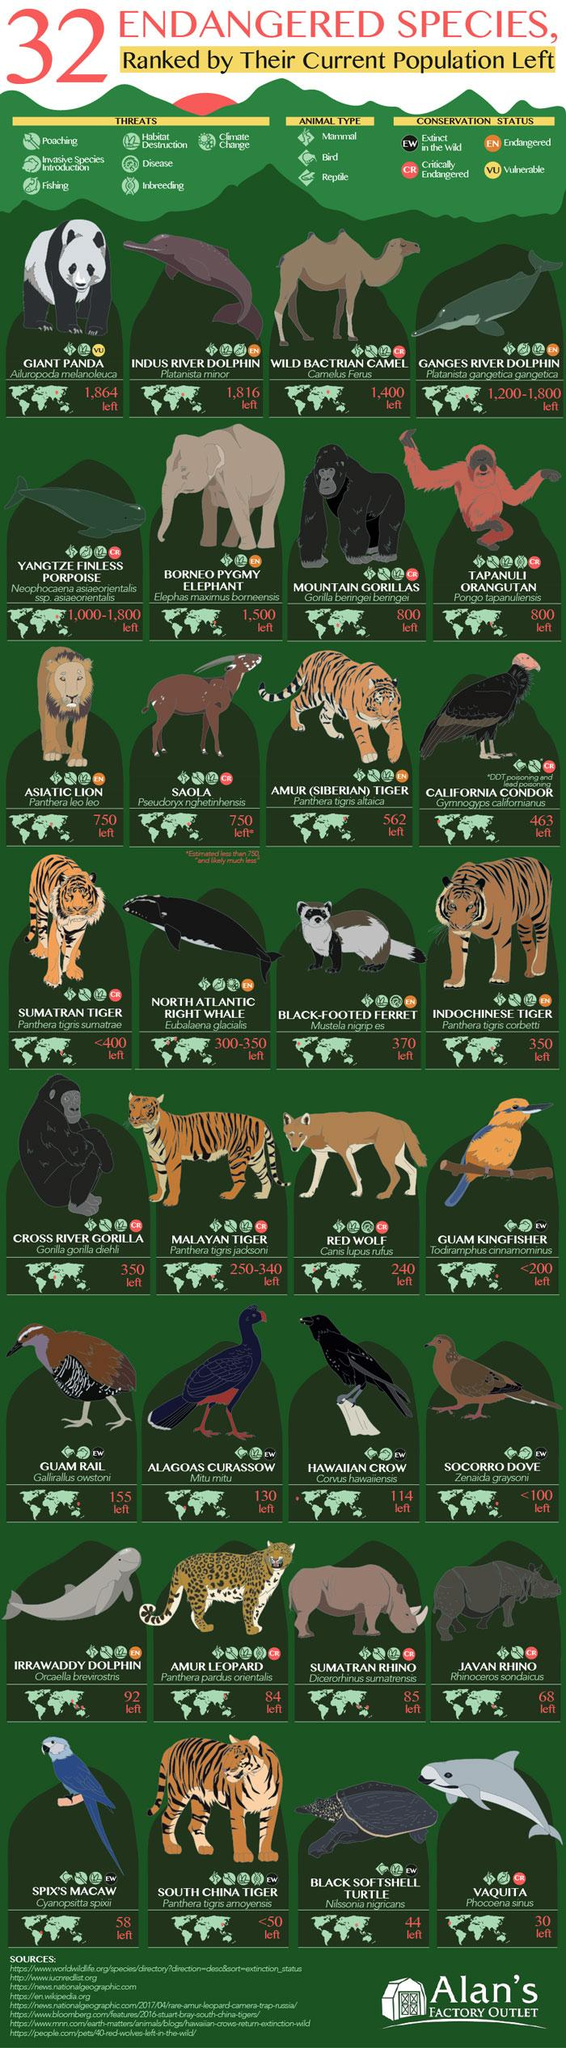Identify some key points in this picture. It is estimated that approximately 2 animals hold the rank of 800. This infographic mentions three types of animals. The infographic mentions 7 threats. It is estimated that approximately 2 animals hold the rank of 750. There are four conservation statuses mentioned in this infographic. 